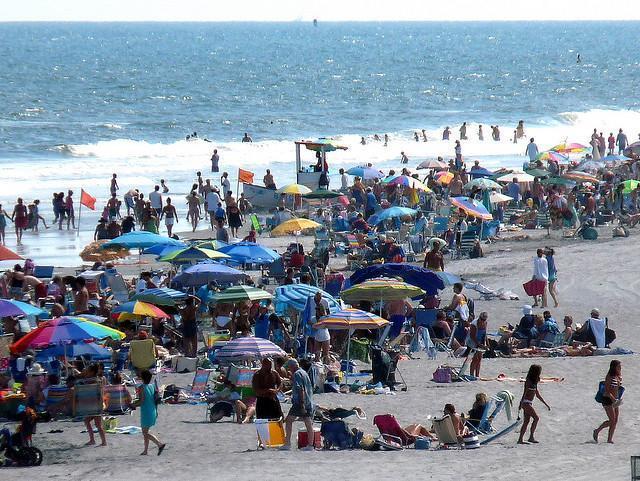How many umbrellas are there?
Give a very brief answer. 2. How many cows are there?
Give a very brief answer. 0. 